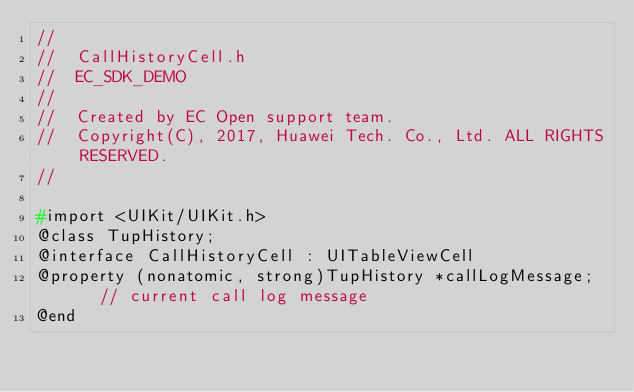Convert code to text. <code><loc_0><loc_0><loc_500><loc_500><_C_>//
//  CallHistoryCell.h
//  EC_SDK_DEMO
//
//  Created by EC Open support team.
//  Copyright(C), 2017, Huawei Tech. Co., Ltd. ALL RIGHTS RESERVED.
//

#import <UIKit/UIKit.h>
@class TupHistory;
@interface CallHistoryCell : UITableViewCell
@property (nonatomic, strong)TupHistory *callLogMessage;    // current call log message
@end
</code> 